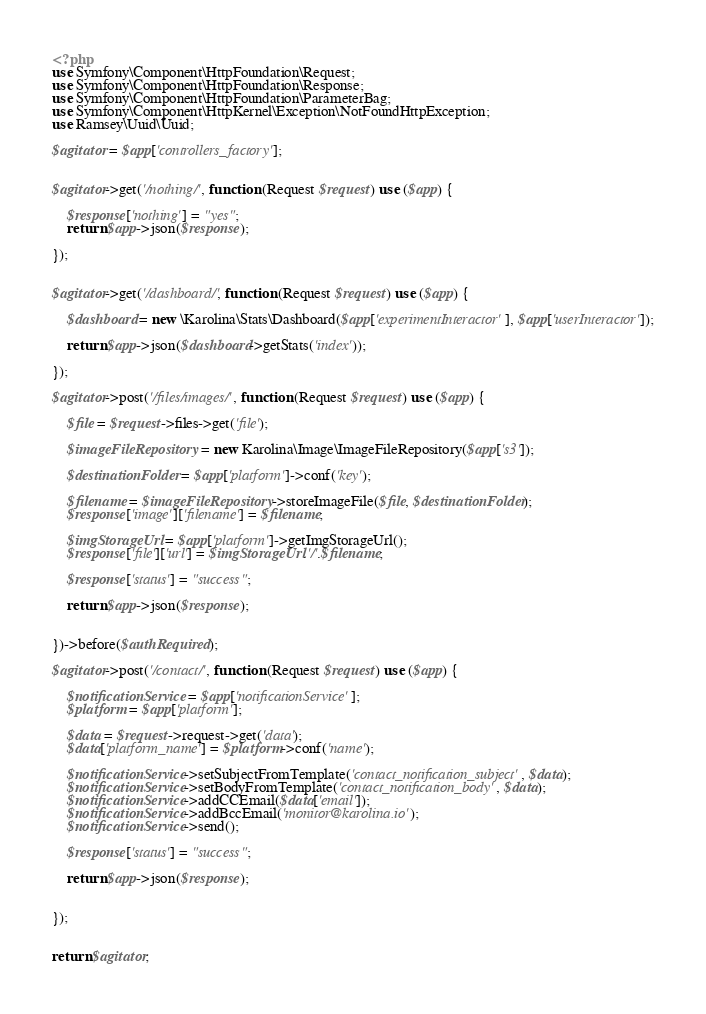Convert code to text. <code><loc_0><loc_0><loc_500><loc_500><_PHP_><?php
use Symfony\Component\HttpFoundation\Request;
use Symfony\Component\HttpFoundation\Response;
use Symfony\Component\HttpFoundation\ParameterBag;
use Symfony\Component\HttpKernel\Exception\NotFoundHttpException;
use Ramsey\Uuid\Uuid;

$agitator = $app['controllers_factory'];


$agitator->get('/nothing/', function (Request $request) use ($app) {

	$response['nothing'] = "yes";
	return $app->json($response);

});


$agitator->get('/dashboard/', function (Request $request) use ($app) {

    $dashboard = new \Karolina\Stats\Dashboard($app['experimentInteractor'], $app['userInteractor']);

    return $app->json($dashboard->getStats('index'));

});

$agitator->post('/files/images/', function (Request $request) use ($app) {

	$file = $request->files->get('file');

	$imageFileRepository = new Karolina\Image\ImageFileRepository($app['s3']);

	$destinationFolder = $app['platform']->conf('key');

	$filename = $imageFileRepository->storeImageFile($file, $destinationFolder);
	$response['image']['filename'] = $filename;

	$imgStorageUrl = $app['platform']->getImgStorageUrl();
	$response['file']['url'] = $imgStorageUrl.'/'.$filename;

	$response['status'] = "success";

	return $app->json($response);


})->before($authRequired);

$agitator->post('/contact/', function (Request $request) use ($app) {

	$notificationService = $app['notificationService'];
	$platform = $app['platform'];

	$data = $request->request->get('data');
	$data['platform_name'] = $platform->conf('name');

	$notificationService->setSubjectFromTemplate('contact_notification_subject', $data);
	$notificationService->setBodyFromTemplate('contact_notification_body', $data);	
	$notificationService->addCCEmail($data['email']);
	$notificationService->addBccEmail('monitor@karolina.io');
	$notificationService->send();

	$response['status'] = "success";

	return $app->json($response);


});


return $agitator;
</code> 